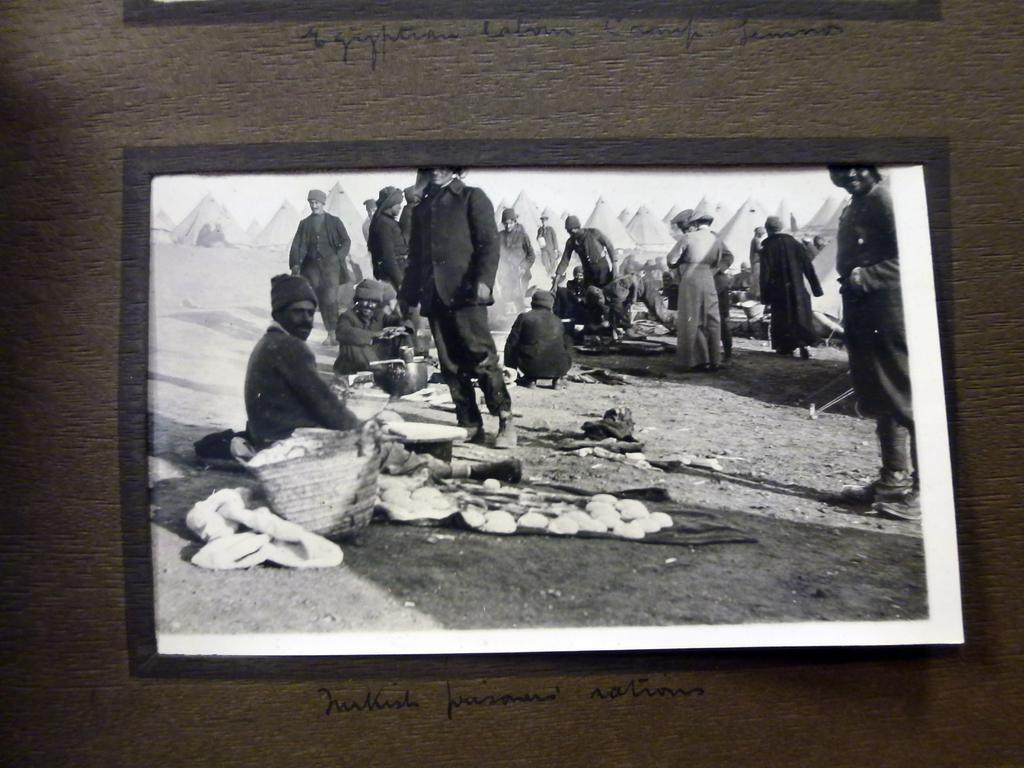What is on the wall in the image? There is a frame on the wall in the image. What can be seen on the wall besides the frame? There is text on the wall in the image. Who or what is present in the image? There are people in the image. What is located near the people in the image? There is a basket in the image. Can you describe any other objects present in the image? There are other objects present in the image, but their specific details are not mentioned in the provided facts. What type of coil is being used by the people in the image? There is no coil present in the image. Can you tell me how many eyes are visible on the wall in the image? There are no eyes visible on the wall in the image. 